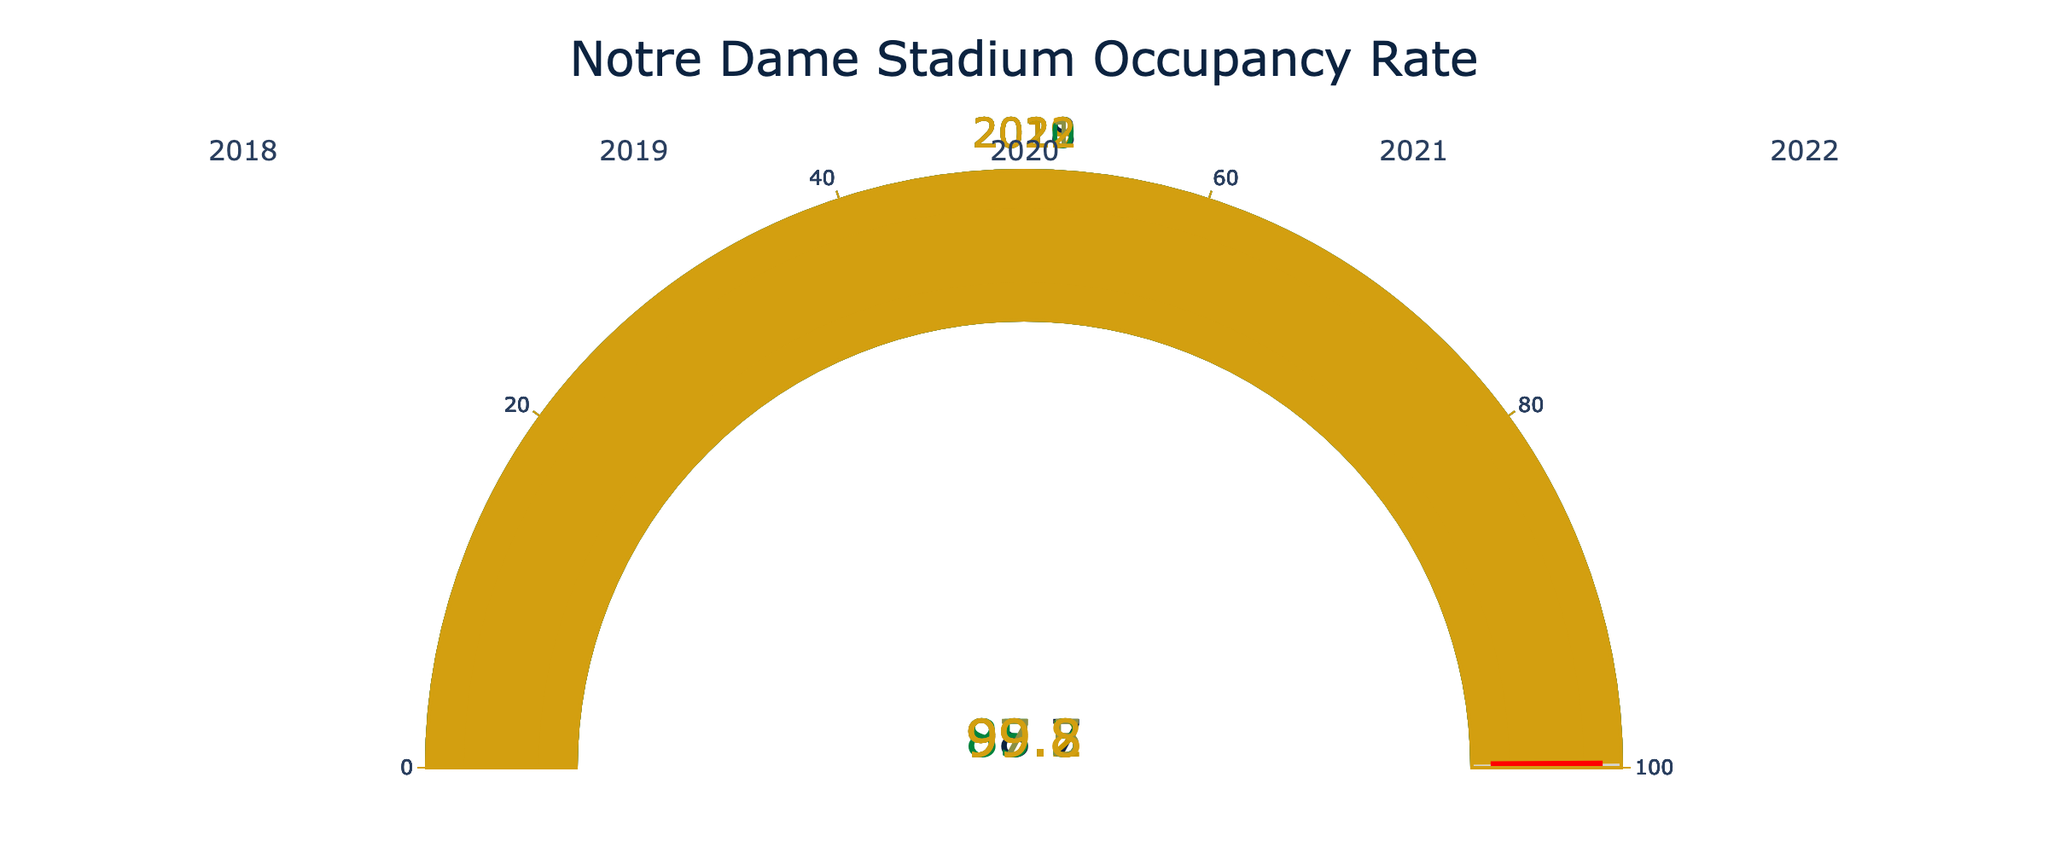What is the title of the gauge chart? The title of the chart can be seen prominently at the top, stating "Notre Dame Stadium Occupancy Rate".
Answer: Notre Dame Stadium Occupancy Rate How many years' data is shown in the chart? Each of the five gauges corresponds to a different year, indicated by the numbers at the top of each gauge.
Answer: 5 Which year had the lowest occupancy rate? By visually inspecting each gauge's number, the year with the lowest rate is the one showing the smallest percentage.
Answer: 2020 In which year did the occupancy rate exceed 99%? Look at the gauge numbers and identify years with rates exceeding 99%. 2019 and 2022 show values over 99%.
Answer: 2019 and 2022 What was the approximate average occupancy rate across all the years displayed? Add the occupancy rates for all five years and divide by 5: (98.7 + 99.2 + 85.3 + 97.5 + 99.8) / 5 ≈ 96.1%
Answer: 96.1% Which year showed an occupancy rate closest to 98%? Compare each year's number to see which rate is closest to 98%. 2018 with 98.7% is closest to 98%.
Answer: 2018 Is there a year where the occupancy rate is less than 90%? Visually inspect each gauge to see if any value is below 90%. 2020 shows 85.3%, which is below 90%.
Answer: 2020 How much did the occupancy rate increase from 2020 to 2021? Subtract the 2020 rate from the 2021 rate: 97.5 - 85.3 = 12.2%.
Answer: 12.2% 